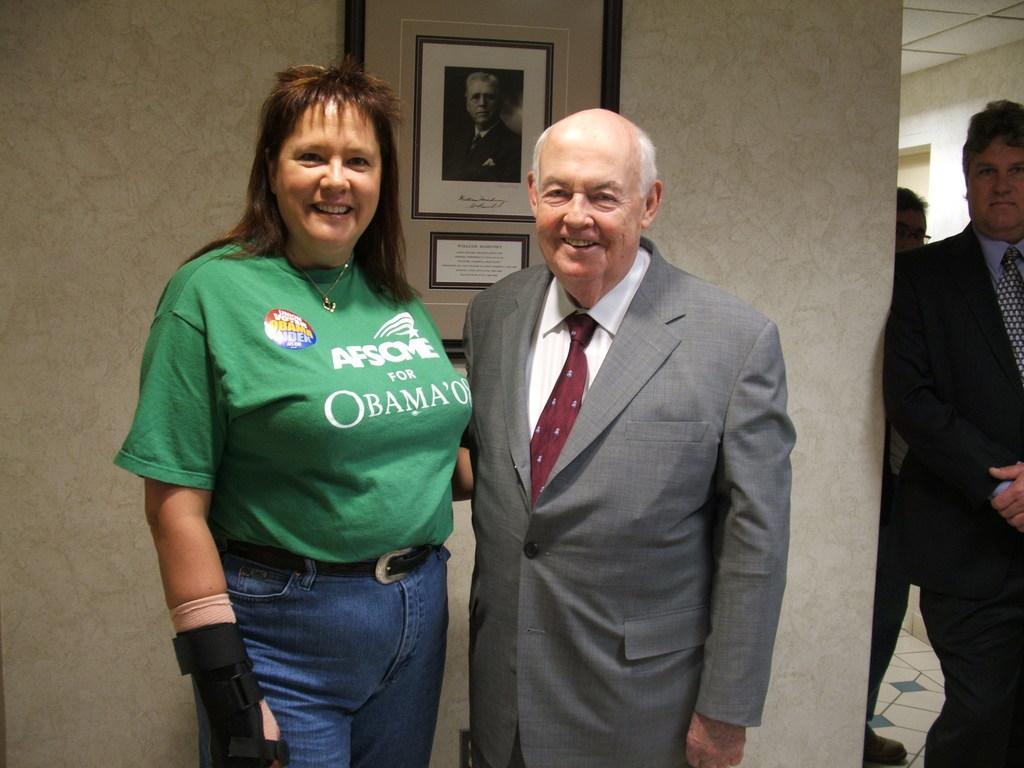Could you give a brief overview of what you see in this image? In this image in the center there is one man and one woman standing, and on the right side there are two people standing and in the background there is a wall and the photo frame. And at the top of the image there is ceiling and at the bottom there is floor. 